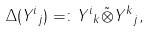Convert formula to latex. <formula><loc_0><loc_0><loc_500><loc_500>\Delta ( { Y ^ { i } } _ { j } ) = \colon { Y ^ { i } } _ { k } \tilde { \otimes } { Y ^ { k } } _ { j } ,</formula> 